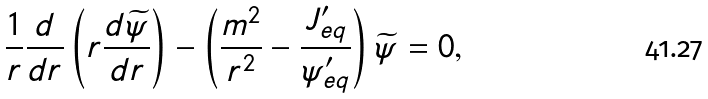Convert formula to latex. <formula><loc_0><loc_0><loc_500><loc_500>\frac { 1 } { r } \frac { d } { d r } \left ( r \frac { d \widetilde { \psi } } { d r } \right ) - \left ( \frac { m ^ { 2 } } { r ^ { 2 } } - \frac { J _ { e q } ^ { \prime } } { \psi _ { e q } ^ { \prime } } \right ) \widetilde { \psi } = 0 ,</formula> 